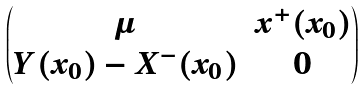<formula> <loc_0><loc_0><loc_500><loc_500>\begin{pmatrix} \mu & x ^ { + } ( x _ { 0 } ) \\ Y ( x _ { 0 } ) - X ^ { - } ( x _ { 0 } ) & 0 \end{pmatrix}</formula> 